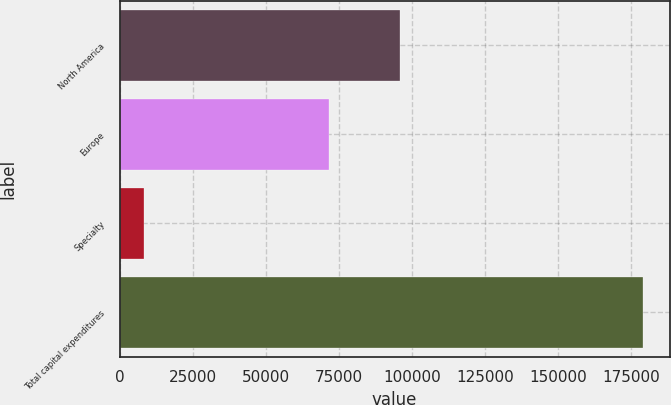Convert chart. <chart><loc_0><loc_0><loc_500><loc_500><bar_chart><fcel>North America<fcel>Europe<fcel>Specialty<fcel>Total capital expenditures<nl><fcel>95823<fcel>71494<fcel>8175<fcel>179090<nl></chart> 